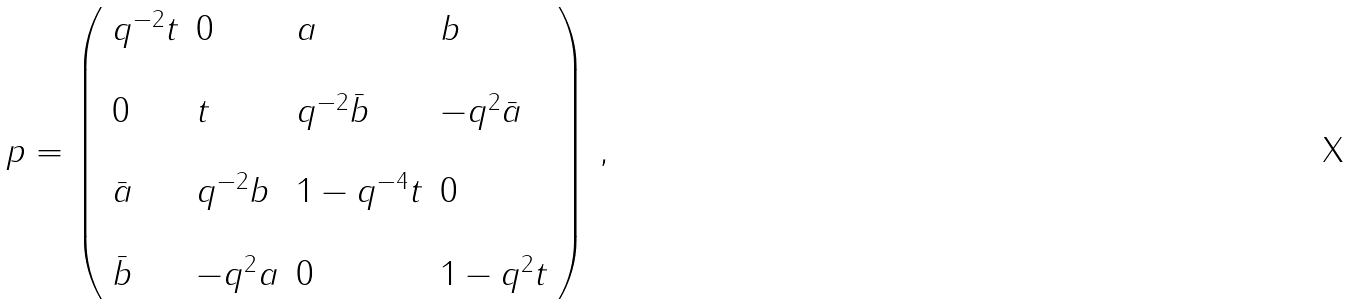Convert formula to latex. <formula><loc_0><loc_0><loc_500><loc_500>p = \left ( \begin{array} { l l l l } q ^ { - 2 } t & 0 & a & b \\ \\ 0 & t & q ^ { - 2 } \bar { b } & - q ^ { 2 } \bar { a } \\ \\ \bar { a } & q ^ { - 2 } b & 1 - q ^ { - 4 } t & 0 \\ \\ \bar { b } & - q ^ { 2 } a & 0 & 1 - q ^ { 2 } t \end{array} \right ) \, ,</formula> 